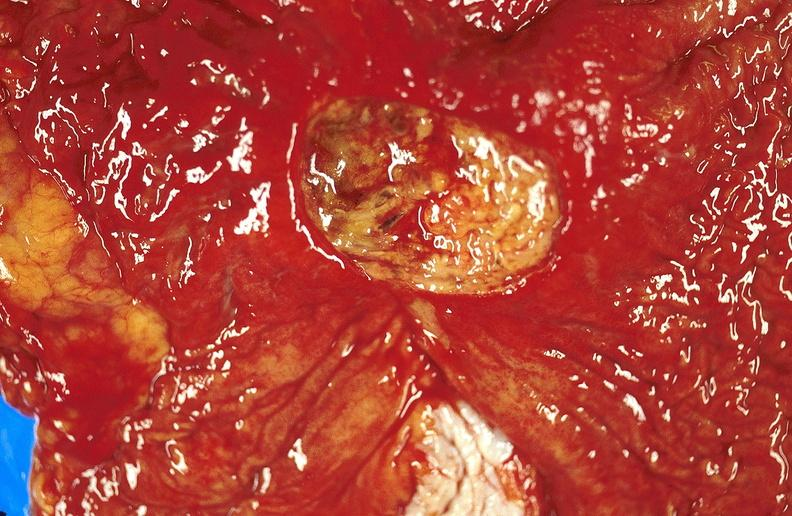does this image show gastric ulcer?
Answer the question using a single word or phrase. Yes 